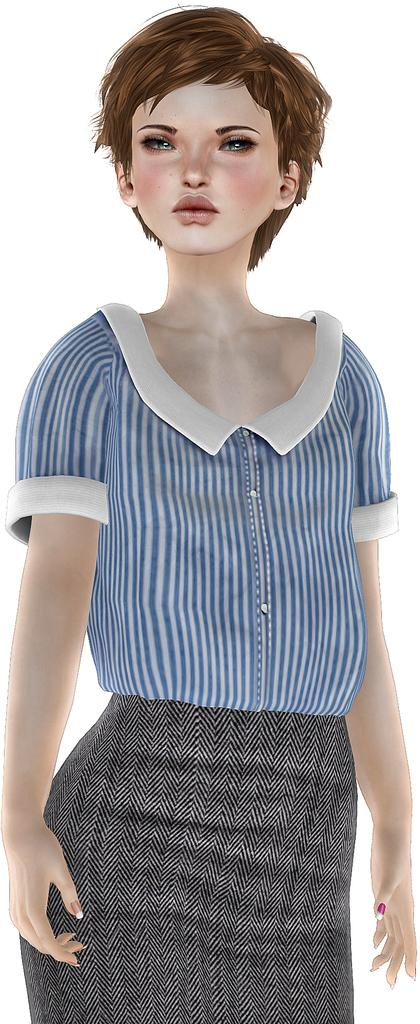What type of image is being described? The image is animated. Can you describe the woman in the image? There is a woman standing in the image. What color is the background of the image? The background of the image is white. Where is the desk located in the image? There is no desk present in the image. What type of alley can be seen in the background of the image? There is no alley present in the image; the background is white. 